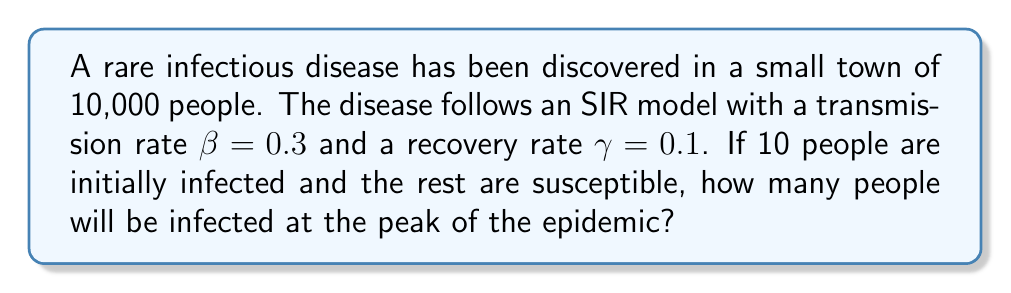Give your solution to this math problem. To solve this problem, we'll use the SIR model and find the maximum number of infected individuals. Let's follow these steps:

1) In the SIR model, the peak of the epidemic occurs when $\frac{dI}{dt} = 0$. This happens when:

   $$\frac{S}{N} = \frac{\gamma}{\beta}$$

   Where $N$ is the total population.

2) We're given:
   $\beta = 0.3$
   $\gamma = 0.1$
   $N = 10,000$

3) Substituting these values:

   $$\frac{S}{10000} = \frac{0.1}{0.3} = \frac{1}{3}$$

4) This means at the peak:
   $S = 10000 \cdot \frac{1}{3} = 3333.33$

5) We can find $R$ (recovered) using the conservation of population:
   $N = S + I + R$
   $10000 = 3333.33 + I + R$

6) At the start, we had 10 infected and 9990 susceptible. The number of people who have been infected by the peak is:
   $9990 - 3333.33 = 6656.67$

7) Of these, some will have recovered. The fraction that has recovered is approximately $\frac{\gamma}{\beta} = \frac{1}{3}$

8) So, the number of recovered at the peak is about:
   $6656.67 \cdot \frac{1}{3} = 2218.89$

9) Therefore, the number of infected at the peak is:
   $I = 10000 - 3333.33 - 2218.89 = 4447.78$

Rounding to the nearest whole number, we get 4448 people infected at the peak.
Answer: 4448 